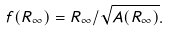Convert formula to latex. <formula><loc_0><loc_0><loc_500><loc_500>f ( R _ { \infty } ) = R _ { \infty } / \sqrt { A ( R _ { \infty } ) } .</formula> 